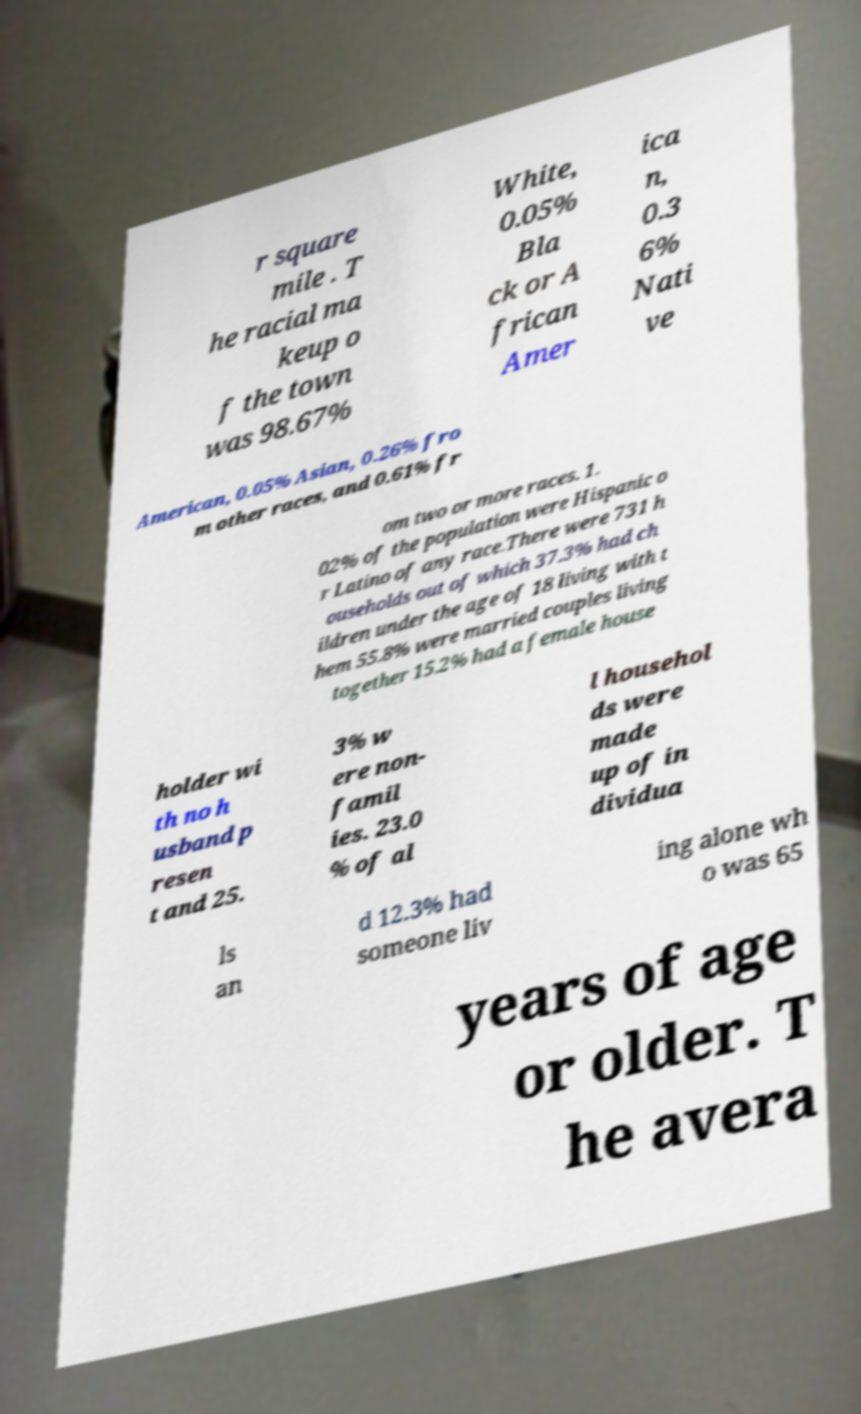What messages or text are displayed in this image? I need them in a readable, typed format. r square mile . T he racial ma keup o f the town was 98.67% White, 0.05% Bla ck or A frican Amer ica n, 0.3 6% Nati ve American, 0.05% Asian, 0.26% fro m other races, and 0.61% fr om two or more races. 1. 02% of the population were Hispanic o r Latino of any race.There were 731 h ouseholds out of which 37.3% had ch ildren under the age of 18 living with t hem 55.8% were married couples living together 15.2% had a female house holder wi th no h usband p resen t and 25. 3% w ere non- famil ies. 23.0 % of al l househol ds were made up of in dividua ls an d 12.3% had someone liv ing alone wh o was 65 years of age or older. T he avera 